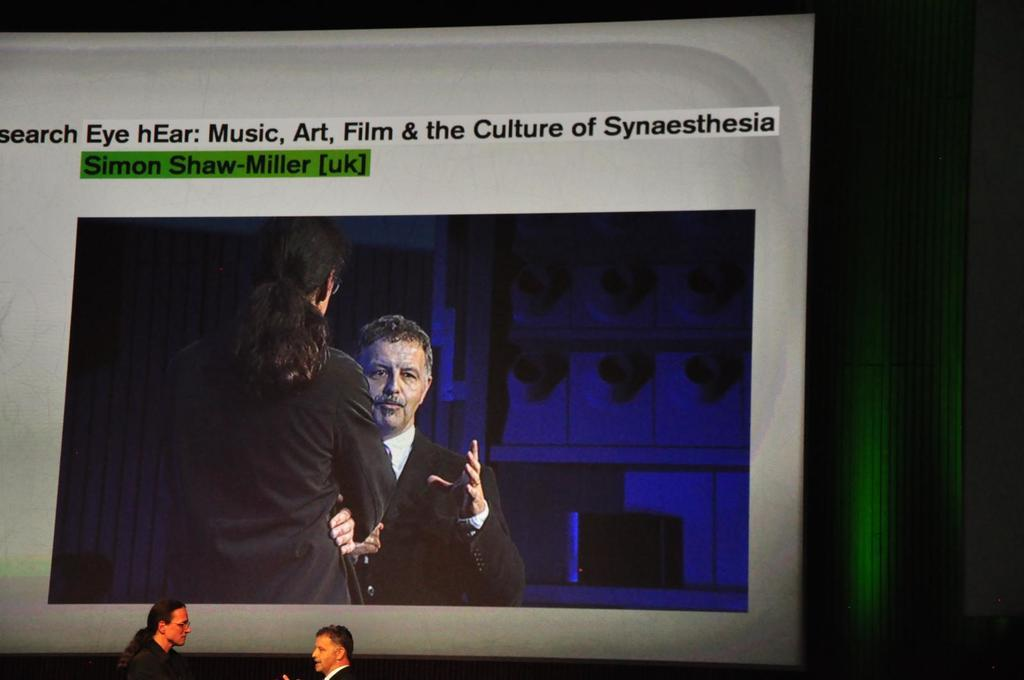What are the two people in the image doing? The two people in the image are standing and talking. What can be seen in the background of the image? There is a screen in the background of the image. What is displayed on the screen? There are two people visible on the screen, and there is text present on the screen. What type of pipe can be seen in the image? There is no pipe present in the image. Is there any bread visible in the image? There is no bread present in the image. 